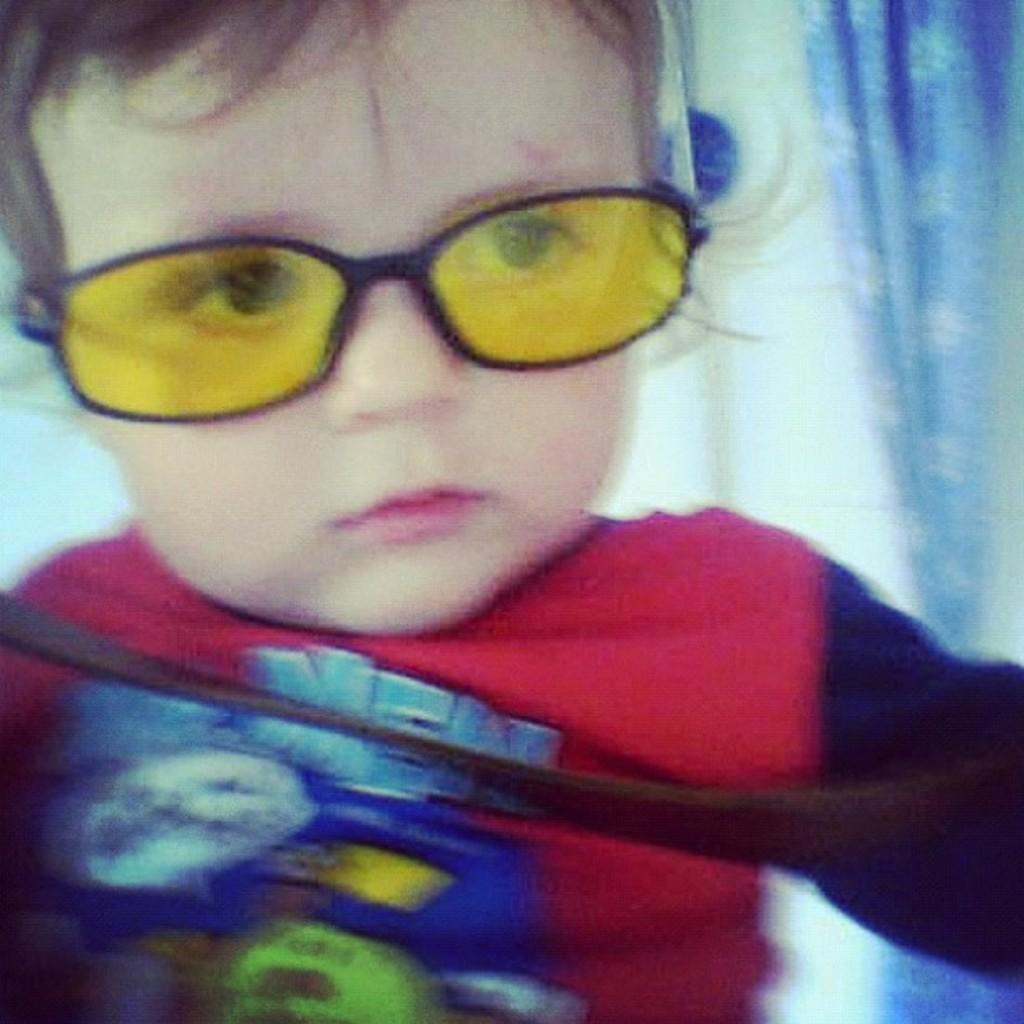What is present in the image? There is a person in the image. Can you describe the person's attire? The person is wearing a dress and specs. What can be seen in the background of the image? There is a blue color curtain and a wall in the background of the image. How would you describe the image's quality? The image is blurred. How many buttons can be seen on the person's dress in the image? There is no mention of buttons on the person's dress in the provided facts, so we cannot determine the number of buttons from the image. Can you describe the person's self-expression in the image? The provided facts do not give any information about the person's self-expression, so we cannot answer this question based on the image. 